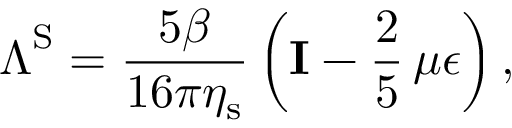Convert formula to latex. <formula><loc_0><loc_0><loc_500><loc_500>\Lambda ^ { S } = \frac { 5 \beta } { 1 6 \pi \eta _ { s } } \left ( I - \frac { 2 } { 5 } \, \mu \epsilon \right ) ,</formula> 